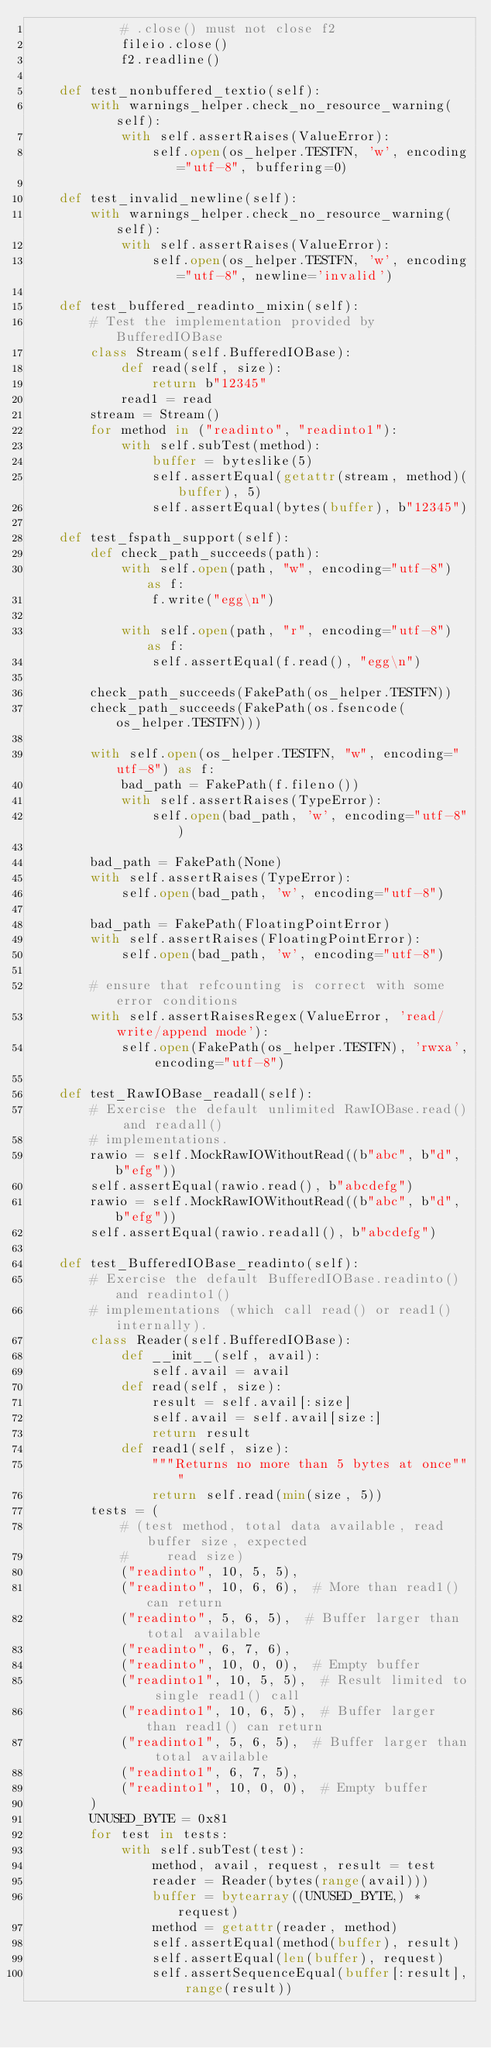<code> <loc_0><loc_0><loc_500><loc_500><_Python_>            # .close() must not close f2
            fileio.close()
            f2.readline()

    def test_nonbuffered_textio(self):
        with warnings_helper.check_no_resource_warning(self):
            with self.assertRaises(ValueError):
                self.open(os_helper.TESTFN, 'w', encoding="utf-8", buffering=0)

    def test_invalid_newline(self):
        with warnings_helper.check_no_resource_warning(self):
            with self.assertRaises(ValueError):
                self.open(os_helper.TESTFN, 'w', encoding="utf-8", newline='invalid')

    def test_buffered_readinto_mixin(self):
        # Test the implementation provided by BufferedIOBase
        class Stream(self.BufferedIOBase):
            def read(self, size):
                return b"12345"
            read1 = read
        stream = Stream()
        for method in ("readinto", "readinto1"):
            with self.subTest(method):
                buffer = byteslike(5)
                self.assertEqual(getattr(stream, method)(buffer), 5)
                self.assertEqual(bytes(buffer), b"12345")

    def test_fspath_support(self):
        def check_path_succeeds(path):
            with self.open(path, "w", encoding="utf-8") as f:
                f.write("egg\n")

            with self.open(path, "r", encoding="utf-8") as f:
                self.assertEqual(f.read(), "egg\n")

        check_path_succeeds(FakePath(os_helper.TESTFN))
        check_path_succeeds(FakePath(os.fsencode(os_helper.TESTFN)))

        with self.open(os_helper.TESTFN, "w", encoding="utf-8") as f:
            bad_path = FakePath(f.fileno())
            with self.assertRaises(TypeError):
                self.open(bad_path, 'w', encoding="utf-8")

        bad_path = FakePath(None)
        with self.assertRaises(TypeError):
            self.open(bad_path, 'w', encoding="utf-8")

        bad_path = FakePath(FloatingPointError)
        with self.assertRaises(FloatingPointError):
            self.open(bad_path, 'w', encoding="utf-8")

        # ensure that refcounting is correct with some error conditions
        with self.assertRaisesRegex(ValueError, 'read/write/append mode'):
            self.open(FakePath(os_helper.TESTFN), 'rwxa', encoding="utf-8")

    def test_RawIOBase_readall(self):
        # Exercise the default unlimited RawIOBase.read() and readall()
        # implementations.
        rawio = self.MockRawIOWithoutRead((b"abc", b"d", b"efg"))
        self.assertEqual(rawio.read(), b"abcdefg")
        rawio = self.MockRawIOWithoutRead((b"abc", b"d", b"efg"))
        self.assertEqual(rawio.readall(), b"abcdefg")

    def test_BufferedIOBase_readinto(self):
        # Exercise the default BufferedIOBase.readinto() and readinto1()
        # implementations (which call read() or read1() internally).
        class Reader(self.BufferedIOBase):
            def __init__(self, avail):
                self.avail = avail
            def read(self, size):
                result = self.avail[:size]
                self.avail = self.avail[size:]
                return result
            def read1(self, size):
                """Returns no more than 5 bytes at once"""
                return self.read(min(size, 5))
        tests = (
            # (test method, total data available, read buffer size, expected
            #     read size)
            ("readinto", 10, 5, 5),
            ("readinto", 10, 6, 6),  # More than read1() can return
            ("readinto", 5, 6, 5),  # Buffer larger than total available
            ("readinto", 6, 7, 6),
            ("readinto", 10, 0, 0),  # Empty buffer
            ("readinto1", 10, 5, 5),  # Result limited to single read1() call
            ("readinto1", 10, 6, 5),  # Buffer larger than read1() can return
            ("readinto1", 5, 6, 5),  # Buffer larger than total available
            ("readinto1", 6, 7, 5),
            ("readinto1", 10, 0, 0),  # Empty buffer
        )
        UNUSED_BYTE = 0x81
        for test in tests:
            with self.subTest(test):
                method, avail, request, result = test
                reader = Reader(bytes(range(avail)))
                buffer = bytearray((UNUSED_BYTE,) * request)
                method = getattr(reader, method)
                self.assertEqual(method(buffer), result)
                self.assertEqual(len(buffer), request)
                self.assertSequenceEqual(buffer[:result], range(result))</code> 